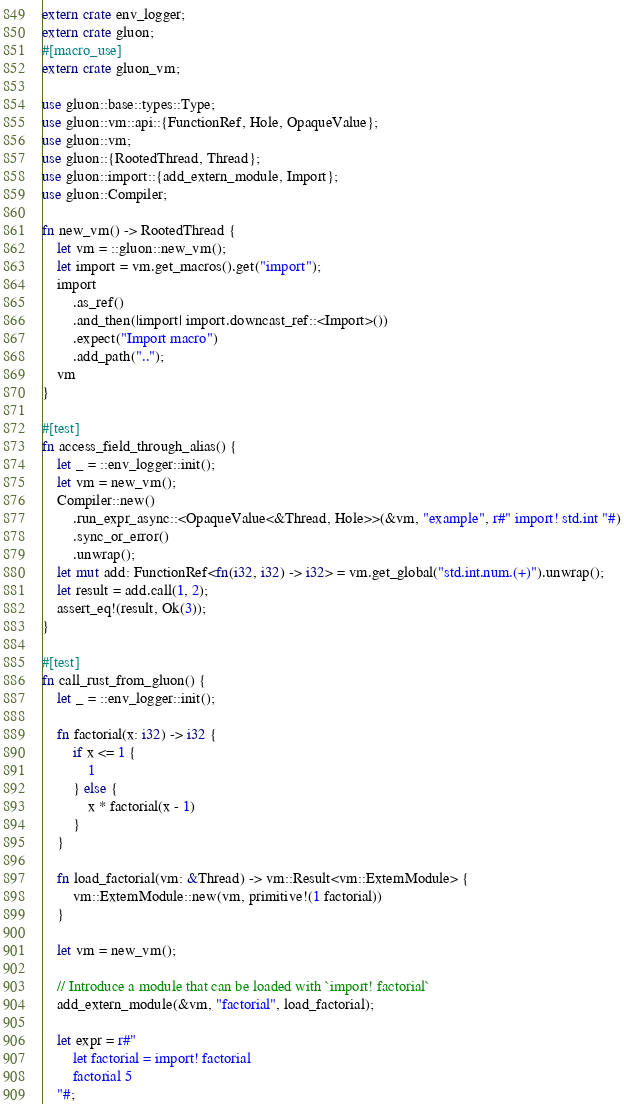Convert code to text. <code><loc_0><loc_0><loc_500><loc_500><_Rust_>extern crate env_logger;
extern crate gluon;
#[macro_use]
extern crate gluon_vm;

use gluon::base::types::Type;
use gluon::vm::api::{FunctionRef, Hole, OpaqueValue};
use gluon::vm;
use gluon::{RootedThread, Thread};
use gluon::import::{add_extern_module, Import};
use gluon::Compiler;

fn new_vm() -> RootedThread {
    let vm = ::gluon::new_vm();
    let import = vm.get_macros().get("import");
    import
        .as_ref()
        .and_then(|import| import.downcast_ref::<Import>())
        .expect("Import macro")
        .add_path("..");
    vm
}

#[test]
fn access_field_through_alias() {
    let _ = ::env_logger::init();
    let vm = new_vm();
    Compiler::new()
        .run_expr_async::<OpaqueValue<&Thread, Hole>>(&vm, "example", r#" import! std.int "#)
        .sync_or_error()
        .unwrap();
    let mut add: FunctionRef<fn(i32, i32) -> i32> = vm.get_global("std.int.num.(+)").unwrap();
    let result = add.call(1, 2);
    assert_eq!(result, Ok(3));
}

#[test]
fn call_rust_from_gluon() {
    let _ = ::env_logger::init();

    fn factorial(x: i32) -> i32 {
        if x <= 1 {
            1
        } else {
            x * factorial(x - 1)
        }
    }

    fn load_factorial(vm: &Thread) -> vm::Result<vm::ExternModule> {
        vm::ExternModule::new(vm, primitive!(1 factorial))
    }

    let vm = new_vm();

    // Introduce a module that can be loaded with `import! factorial`
    add_extern_module(&vm, "factorial", load_factorial);

    let expr = r#"
        let factorial = import! factorial
        factorial 5
    "#;
</code> 